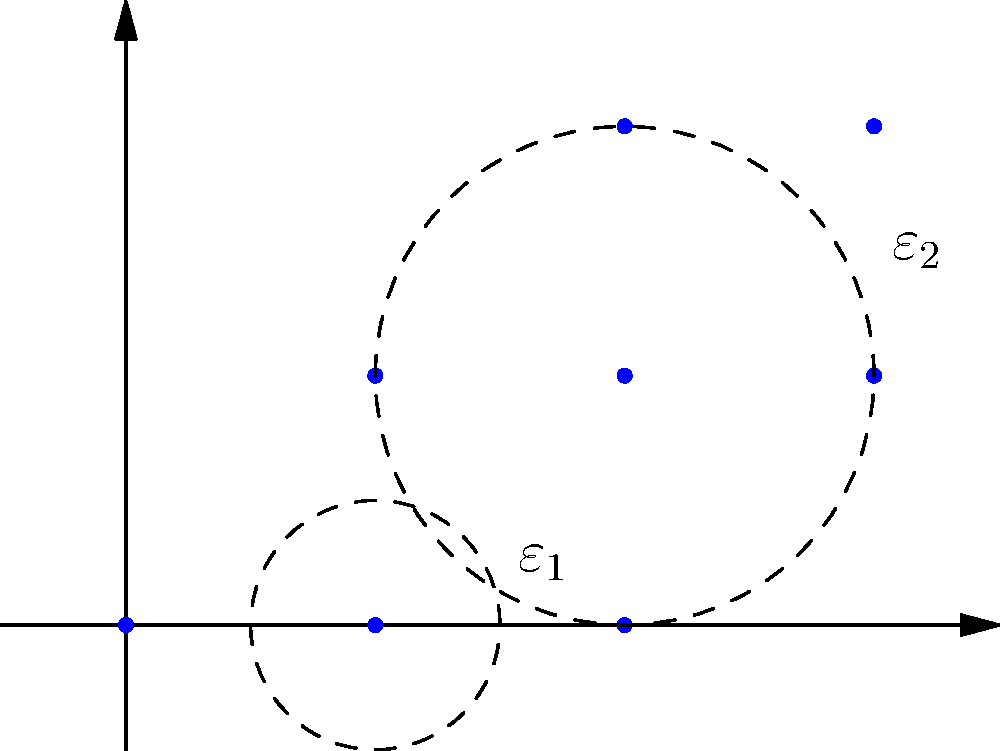Given the 2D point cloud dataset shown in the figure, what is the first Betti number (β₁) of the Vietoris-Rips complex at filtration value ε₂? How does this relate to the persistent homology of the dataset? To answer this question, we need to analyze the Vietoris-Rips complex at filtration value ε₂ and understand its implications for persistent homology:

1. Observe the point cloud: We have 8 points in 2D space.

2. Understand Vietoris-Rips complex: At a given filtration value ε, we connect points with edges if their distance is less than or equal to ε.

3. Analyze at ε₂:
   - All points within the large circle (radius ε₂) are connected.
   - This forms a single connected component.
   - We observe one loop (cycle) formed by the points (1,1), (2,1), (2,2), and (3,1).

4. Calculate Betti numbers:
   - β₀ (number of connected components) = 1
   - β₁ (number of 1-dimensional holes) = 1
   - β₂ (number of 2-dimensional voids) = 0

5. Interpret for persistent homology:
   - The β₁ = 1 at ε₂ indicates a persistent 1-dimensional feature (loop) in the data.
   - This loop persists from its birth at some ε < ε₂ until it dies at some ε > ε₂.
   - The persistence of this feature suggests it's a significant topological characteristic of the dataset, not just noise.

6. Relevance to CEO perspective:
   - Persistent homology helps identify robust features in data, which can be valuable for pattern recognition, anomaly detection, or data compression in technology products.
Answer: β₁ = 1; indicates a persistent 1-dimensional feature (loop) in the data 